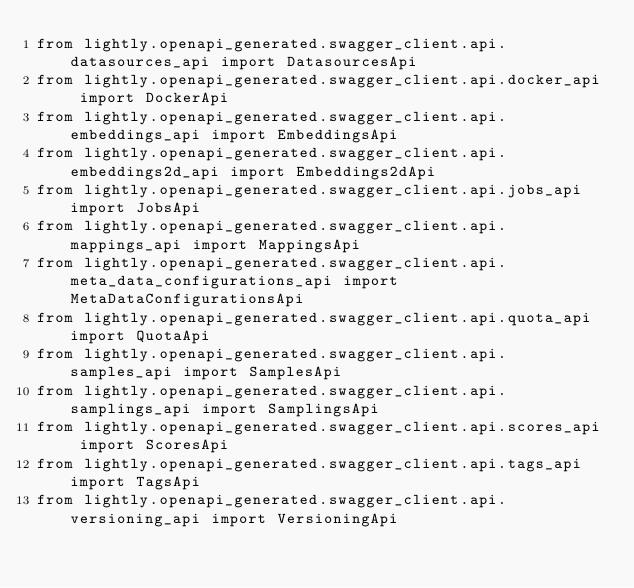<code> <loc_0><loc_0><loc_500><loc_500><_Python_>from lightly.openapi_generated.swagger_client.api.datasources_api import DatasourcesApi
from lightly.openapi_generated.swagger_client.api.docker_api import DockerApi
from lightly.openapi_generated.swagger_client.api.embeddings_api import EmbeddingsApi
from lightly.openapi_generated.swagger_client.api.embeddings2d_api import Embeddings2dApi
from lightly.openapi_generated.swagger_client.api.jobs_api import JobsApi
from lightly.openapi_generated.swagger_client.api.mappings_api import MappingsApi
from lightly.openapi_generated.swagger_client.api.meta_data_configurations_api import MetaDataConfigurationsApi
from lightly.openapi_generated.swagger_client.api.quota_api import QuotaApi
from lightly.openapi_generated.swagger_client.api.samples_api import SamplesApi
from lightly.openapi_generated.swagger_client.api.samplings_api import SamplingsApi
from lightly.openapi_generated.swagger_client.api.scores_api import ScoresApi
from lightly.openapi_generated.swagger_client.api.tags_api import TagsApi
from lightly.openapi_generated.swagger_client.api.versioning_api import VersioningApi
</code> 